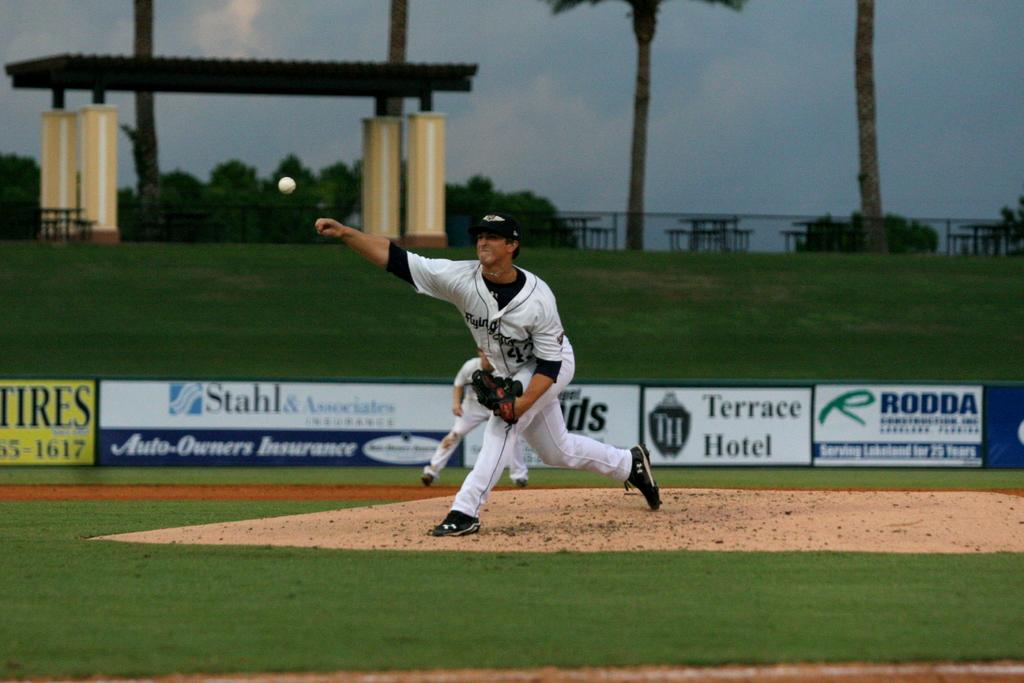What hotel is a sponsor?
Your answer should be very brief. Terrace hotel. What kind of business is terrace?
Provide a succinct answer. Hotel. 